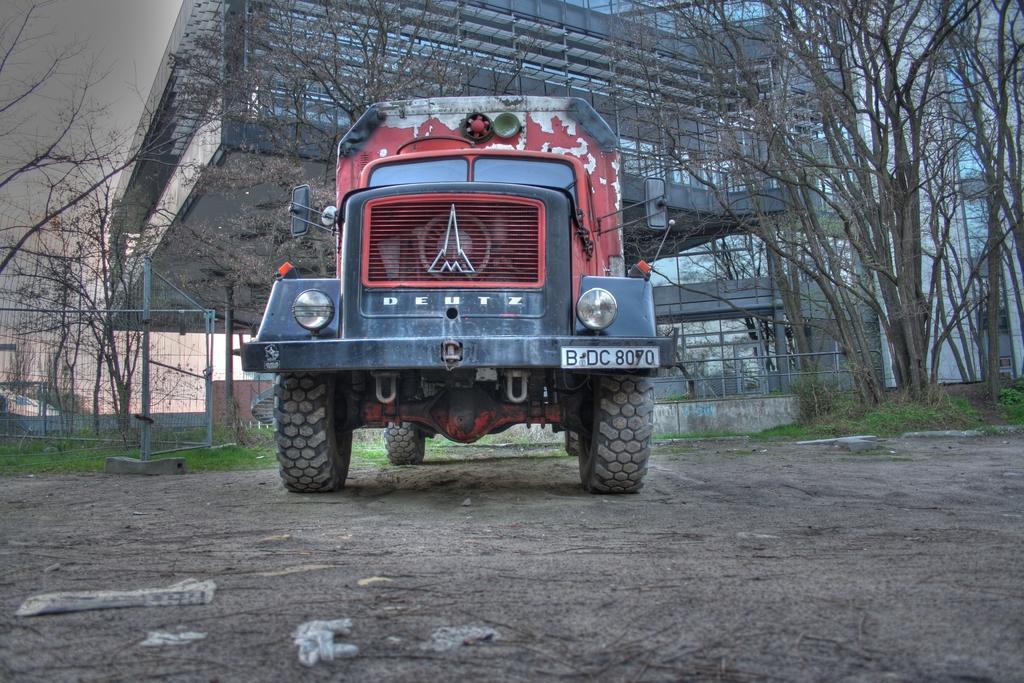In one or two sentences, can you explain what this image depicts? In this image we can see a truck with a number plate. In the back there are railings, trees and buildings. In the background there is sky. On the ground there is grass. 